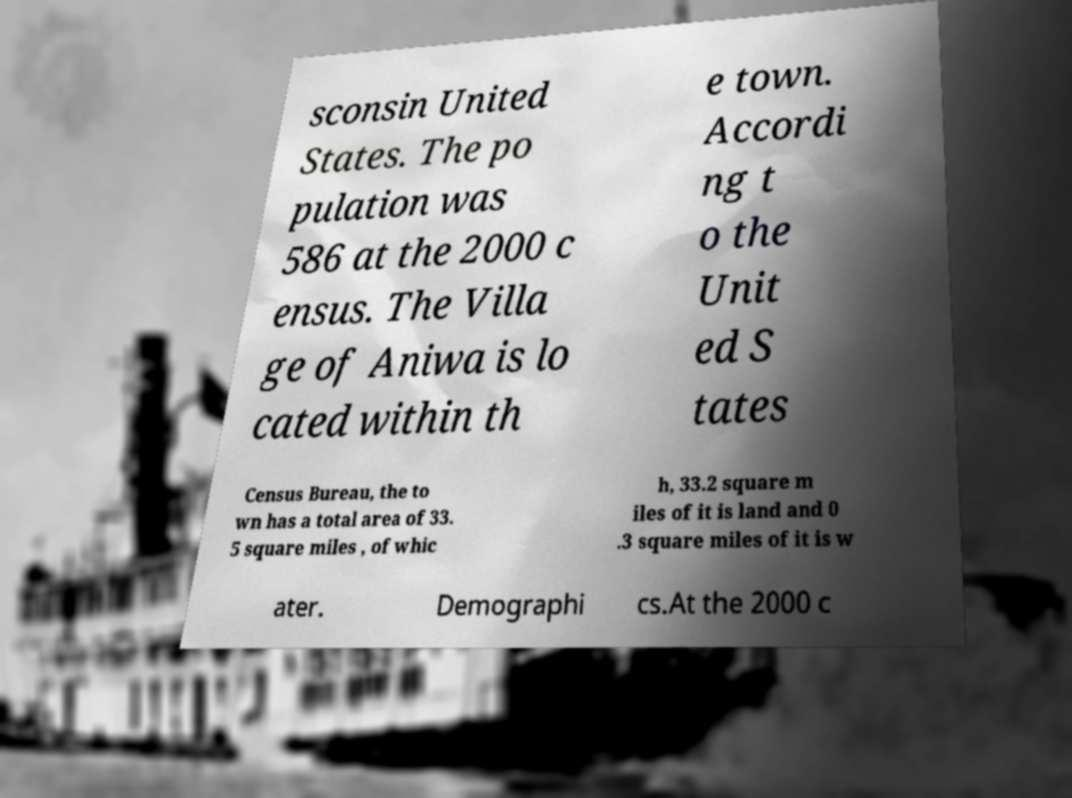Can you read and provide the text displayed in the image?This photo seems to have some interesting text. Can you extract and type it out for me? sconsin United States. The po pulation was 586 at the 2000 c ensus. The Villa ge of Aniwa is lo cated within th e town. Accordi ng t o the Unit ed S tates Census Bureau, the to wn has a total area of 33. 5 square miles , of whic h, 33.2 square m iles of it is land and 0 .3 square miles of it is w ater. Demographi cs.At the 2000 c 